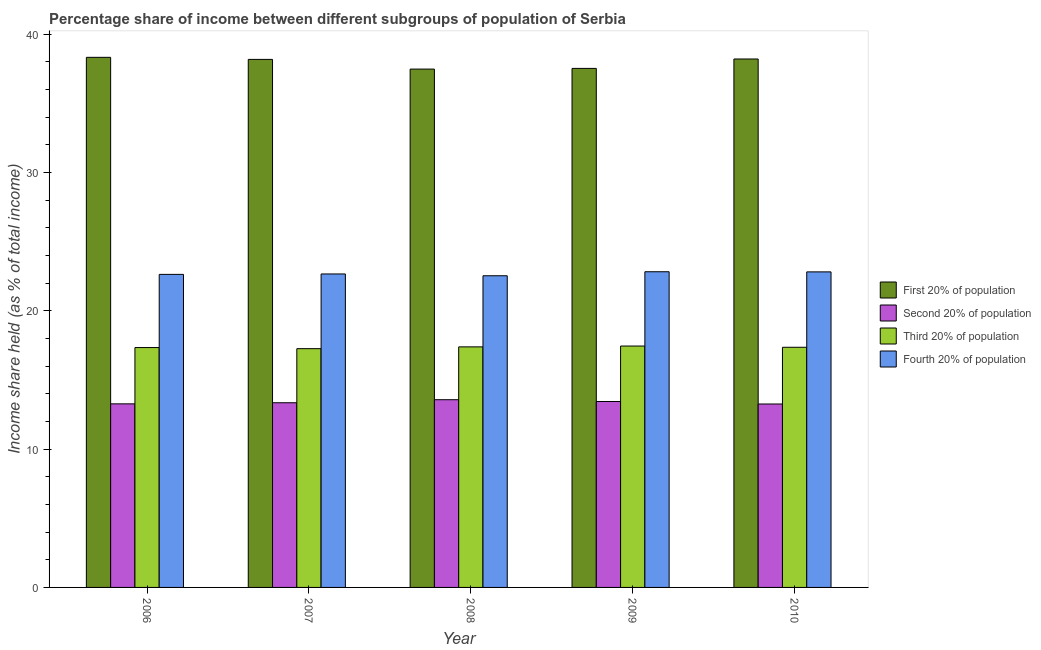Are the number of bars per tick equal to the number of legend labels?
Ensure brevity in your answer.  Yes. How many bars are there on the 2nd tick from the left?
Keep it short and to the point. 4. What is the label of the 2nd group of bars from the left?
Offer a very short reply. 2007. What is the share of the income held by fourth 20% of the population in 2007?
Offer a terse response. 22.66. Across all years, what is the maximum share of the income held by fourth 20% of the population?
Keep it short and to the point. 22.82. Across all years, what is the minimum share of the income held by first 20% of the population?
Offer a very short reply. 37.47. What is the total share of the income held by second 20% of the population in the graph?
Ensure brevity in your answer.  66.89. What is the difference between the share of the income held by third 20% of the population in 2006 and that in 2010?
Ensure brevity in your answer.  -0.02. What is the difference between the share of the income held by first 20% of the population in 2007 and the share of the income held by third 20% of the population in 2006?
Offer a very short reply. -0.15. What is the average share of the income held by third 20% of the population per year?
Provide a short and direct response. 17.36. What is the ratio of the share of the income held by first 20% of the population in 2006 to that in 2007?
Keep it short and to the point. 1. Is the difference between the share of the income held by second 20% of the population in 2008 and 2010 greater than the difference between the share of the income held by first 20% of the population in 2008 and 2010?
Offer a terse response. No. What is the difference between the highest and the second highest share of the income held by first 20% of the population?
Keep it short and to the point. 0.12. What is the difference between the highest and the lowest share of the income held by third 20% of the population?
Offer a terse response. 0.19. In how many years, is the share of the income held by third 20% of the population greater than the average share of the income held by third 20% of the population taken over all years?
Give a very brief answer. 2. What does the 4th bar from the left in 2009 represents?
Make the answer very short. Fourth 20% of population. What does the 3rd bar from the right in 2009 represents?
Offer a very short reply. Second 20% of population. Is it the case that in every year, the sum of the share of the income held by first 20% of the population and share of the income held by second 20% of the population is greater than the share of the income held by third 20% of the population?
Offer a terse response. Yes. How many years are there in the graph?
Your answer should be very brief. 5. What is the difference between two consecutive major ticks on the Y-axis?
Provide a short and direct response. 10. Are the values on the major ticks of Y-axis written in scientific E-notation?
Offer a very short reply. No. Does the graph contain grids?
Provide a short and direct response. No. Where does the legend appear in the graph?
Your answer should be compact. Center right. How are the legend labels stacked?
Offer a terse response. Vertical. What is the title of the graph?
Offer a very short reply. Percentage share of income between different subgroups of population of Serbia. What is the label or title of the Y-axis?
Ensure brevity in your answer.  Income share held (as % of total income). What is the Income share held (as % of total income) in First 20% of population in 2006?
Provide a short and direct response. 38.32. What is the Income share held (as % of total income) of Second 20% of population in 2006?
Provide a short and direct response. 13.27. What is the Income share held (as % of total income) of Third 20% of population in 2006?
Your answer should be very brief. 17.34. What is the Income share held (as % of total income) in Fourth 20% of population in 2006?
Your answer should be very brief. 22.63. What is the Income share held (as % of total income) of First 20% of population in 2007?
Make the answer very short. 38.17. What is the Income share held (as % of total income) of Second 20% of population in 2007?
Provide a short and direct response. 13.35. What is the Income share held (as % of total income) of Third 20% of population in 2007?
Provide a succinct answer. 17.26. What is the Income share held (as % of total income) of Fourth 20% of population in 2007?
Ensure brevity in your answer.  22.66. What is the Income share held (as % of total income) in First 20% of population in 2008?
Offer a terse response. 37.47. What is the Income share held (as % of total income) in Second 20% of population in 2008?
Provide a short and direct response. 13.57. What is the Income share held (as % of total income) in Third 20% of population in 2008?
Your answer should be compact. 17.39. What is the Income share held (as % of total income) of Fourth 20% of population in 2008?
Offer a terse response. 22.53. What is the Income share held (as % of total income) in First 20% of population in 2009?
Offer a very short reply. 37.52. What is the Income share held (as % of total income) of Second 20% of population in 2009?
Your response must be concise. 13.44. What is the Income share held (as % of total income) in Third 20% of population in 2009?
Keep it short and to the point. 17.45. What is the Income share held (as % of total income) in Fourth 20% of population in 2009?
Make the answer very short. 22.82. What is the Income share held (as % of total income) in First 20% of population in 2010?
Your answer should be compact. 38.2. What is the Income share held (as % of total income) in Second 20% of population in 2010?
Make the answer very short. 13.26. What is the Income share held (as % of total income) in Third 20% of population in 2010?
Offer a terse response. 17.36. What is the Income share held (as % of total income) in Fourth 20% of population in 2010?
Your answer should be very brief. 22.81. Across all years, what is the maximum Income share held (as % of total income) in First 20% of population?
Make the answer very short. 38.32. Across all years, what is the maximum Income share held (as % of total income) of Second 20% of population?
Give a very brief answer. 13.57. Across all years, what is the maximum Income share held (as % of total income) in Third 20% of population?
Your answer should be compact. 17.45. Across all years, what is the maximum Income share held (as % of total income) of Fourth 20% of population?
Your answer should be compact. 22.82. Across all years, what is the minimum Income share held (as % of total income) in First 20% of population?
Your answer should be very brief. 37.47. Across all years, what is the minimum Income share held (as % of total income) in Second 20% of population?
Offer a very short reply. 13.26. Across all years, what is the minimum Income share held (as % of total income) of Third 20% of population?
Give a very brief answer. 17.26. Across all years, what is the minimum Income share held (as % of total income) in Fourth 20% of population?
Your answer should be very brief. 22.53. What is the total Income share held (as % of total income) in First 20% of population in the graph?
Make the answer very short. 189.68. What is the total Income share held (as % of total income) in Second 20% of population in the graph?
Give a very brief answer. 66.89. What is the total Income share held (as % of total income) in Third 20% of population in the graph?
Your response must be concise. 86.8. What is the total Income share held (as % of total income) in Fourth 20% of population in the graph?
Provide a succinct answer. 113.45. What is the difference between the Income share held (as % of total income) in Second 20% of population in 2006 and that in 2007?
Provide a short and direct response. -0.08. What is the difference between the Income share held (as % of total income) of Fourth 20% of population in 2006 and that in 2007?
Your answer should be very brief. -0.03. What is the difference between the Income share held (as % of total income) in First 20% of population in 2006 and that in 2008?
Make the answer very short. 0.85. What is the difference between the Income share held (as % of total income) in Third 20% of population in 2006 and that in 2008?
Ensure brevity in your answer.  -0.05. What is the difference between the Income share held (as % of total income) of Fourth 20% of population in 2006 and that in 2008?
Make the answer very short. 0.1. What is the difference between the Income share held (as % of total income) in Second 20% of population in 2006 and that in 2009?
Make the answer very short. -0.17. What is the difference between the Income share held (as % of total income) in Third 20% of population in 2006 and that in 2009?
Provide a succinct answer. -0.11. What is the difference between the Income share held (as % of total income) in Fourth 20% of population in 2006 and that in 2009?
Keep it short and to the point. -0.19. What is the difference between the Income share held (as % of total income) of First 20% of population in 2006 and that in 2010?
Your answer should be very brief. 0.12. What is the difference between the Income share held (as % of total income) of Second 20% of population in 2006 and that in 2010?
Keep it short and to the point. 0.01. What is the difference between the Income share held (as % of total income) of Third 20% of population in 2006 and that in 2010?
Provide a succinct answer. -0.02. What is the difference between the Income share held (as % of total income) in Fourth 20% of population in 2006 and that in 2010?
Make the answer very short. -0.18. What is the difference between the Income share held (as % of total income) in Second 20% of population in 2007 and that in 2008?
Your answer should be compact. -0.22. What is the difference between the Income share held (as % of total income) of Third 20% of population in 2007 and that in 2008?
Keep it short and to the point. -0.13. What is the difference between the Income share held (as % of total income) in Fourth 20% of population in 2007 and that in 2008?
Your answer should be compact. 0.13. What is the difference between the Income share held (as % of total income) in First 20% of population in 2007 and that in 2009?
Keep it short and to the point. 0.65. What is the difference between the Income share held (as % of total income) of Second 20% of population in 2007 and that in 2009?
Provide a succinct answer. -0.09. What is the difference between the Income share held (as % of total income) in Third 20% of population in 2007 and that in 2009?
Make the answer very short. -0.19. What is the difference between the Income share held (as % of total income) in Fourth 20% of population in 2007 and that in 2009?
Your answer should be compact. -0.16. What is the difference between the Income share held (as % of total income) in First 20% of population in 2007 and that in 2010?
Offer a terse response. -0.03. What is the difference between the Income share held (as % of total income) of Second 20% of population in 2007 and that in 2010?
Offer a very short reply. 0.09. What is the difference between the Income share held (as % of total income) of Fourth 20% of population in 2007 and that in 2010?
Provide a short and direct response. -0.15. What is the difference between the Income share held (as % of total income) in Second 20% of population in 2008 and that in 2009?
Offer a terse response. 0.13. What is the difference between the Income share held (as % of total income) of Third 20% of population in 2008 and that in 2009?
Provide a short and direct response. -0.06. What is the difference between the Income share held (as % of total income) in Fourth 20% of population in 2008 and that in 2009?
Your answer should be compact. -0.29. What is the difference between the Income share held (as % of total income) of First 20% of population in 2008 and that in 2010?
Give a very brief answer. -0.73. What is the difference between the Income share held (as % of total income) in Second 20% of population in 2008 and that in 2010?
Give a very brief answer. 0.31. What is the difference between the Income share held (as % of total income) in Fourth 20% of population in 2008 and that in 2010?
Your response must be concise. -0.28. What is the difference between the Income share held (as % of total income) of First 20% of population in 2009 and that in 2010?
Your answer should be compact. -0.68. What is the difference between the Income share held (as % of total income) of Second 20% of population in 2009 and that in 2010?
Your answer should be compact. 0.18. What is the difference between the Income share held (as % of total income) of Third 20% of population in 2009 and that in 2010?
Provide a short and direct response. 0.09. What is the difference between the Income share held (as % of total income) of Fourth 20% of population in 2009 and that in 2010?
Make the answer very short. 0.01. What is the difference between the Income share held (as % of total income) of First 20% of population in 2006 and the Income share held (as % of total income) of Second 20% of population in 2007?
Offer a very short reply. 24.97. What is the difference between the Income share held (as % of total income) in First 20% of population in 2006 and the Income share held (as % of total income) in Third 20% of population in 2007?
Offer a very short reply. 21.06. What is the difference between the Income share held (as % of total income) in First 20% of population in 2006 and the Income share held (as % of total income) in Fourth 20% of population in 2007?
Provide a succinct answer. 15.66. What is the difference between the Income share held (as % of total income) in Second 20% of population in 2006 and the Income share held (as % of total income) in Third 20% of population in 2007?
Keep it short and to the point. -3.99. What is the difference between the Income share held (as % of total income) of Second 20% of population in 2006 and the Income share held (as % of total income) of Fourth 20% of population in 2007?
Make the answer very short. -9.39. What is the difference between the Income share held (as % of total income) in Third 20% of population in 2006 and the Income share held (as % of total income) in Fourth 20% of population in 2007?
Your response must be concise. -5.32. What is the difference between the Income share held (as % of total income) in First 20% of population in 2006 and the Income share held (as % of total income) in Second 20% of population in 2008?
Ensure brevity in your answer.  24.75. What is the difference between the Income share held (as % of total income) of First 20% of population in 2006 and the Income share held (as % of total income) of Third 20% of population in 2008?
Your answer should be compact. 20.93. What is the difference between the Income share held (as % of total income) in First 20% of population in 2006 and the Income share held (as % of total income) in Fourth 20% of population in 2008?
Ensure brevity in your answer.  15.79. What is the difference between the Income share held (as % of total income) of Second 20% of population in 2006 and the Income share held (as % of total income) of Third 20% of population in 2008?
Offer a terse response. -4.12. What is the difference between the Income share held (as % of total income) of Second 20% of population in 2006 and the Income share held (as % of total income) of Fourth 20% of population in 2008?
Your response must be concise. -9.26. What is the difference between the Income share held (as % of total income) of Third 20% of population in 2006 and the Income share held (as % of total income) of Fourth 20% of population in 2008?
Provide a succinct answer. -5.19. What is the difference between the Income share held (as % of total income) of First 20% of population in 2006 and the Income share held (as % of total income) of Second 20% of population in 2009?
Your answer should be very brief. 24.88. What is the difference between the Income share held (as % of total income) in First 20% of population in 2006 and the Income share held (as % of total income) in Third 20% of population in 2009?
Ensure brevity in your answer.  20.87. What is the difference between the Income share held (as % of total income) of First 20% of population in 2006 and the Income share held (as % of total income) of Fourth 20% of population in 2009?
Your response must be concise. 15.5. What is the difference between the Income share held (as % of total income) of Second 20% of population in 2006 and the Income share held (as % of total income) of Third 20% of population in 2009?
Offer a very short reply. -4.18. What is the difference between the Income share held (as % of total income) of Second 20% of population in 2006 and the Income share held (as % of total income) of Fourth 20% of population in 2009?
Offer a very short reply. -9.55. What is the difference between the Income share held (as % of total income) of Third 20% of population in 2006 and the Income share held (as % of total income) of Fourth 20% of population in 2009?
Make the answer very short. -5.48. What is the difference between the Income share held (as % of total income) of First 20% of population in 2006 and the Income share held (as % of total income) of Second 20% of population in 2010?
Your answer should be very brief. 25.06. What is the difference between the Income share held (as % of total income) in First 20% of population in 2006 and the Income share held (as % of total income) in Third 20% of population in 2010?
Make the answer very short. 20.96. What is the difference between the Income share held (as % of total income) of First 20% of population in 2006 and the Income share held (as % of total income) of Fourth 20% of population in 2010?
Provide a succinct answer. 15.51. What is the difference between the Income share held (as % of total income) in Second 20% of population in 2006 and the Income share held (as % of total income) in Third 20% of population in 2010?
Offer a very short reply. -4.09. What is the difference between the Income share held (as % of total income) in Second 20% of population in 2006 and the Income share held (as % of total income) in Fourth 20% of population in 2010?
Offer a very short reply. -9.54. What is the difference between the Income share held (as % of total income) of Third 20% of population in 2006 and the Income share held (as % of total income) of Fourth 20% of population in 2010?
Give a very brief answer. -5.47. What is the difference between the Income share held (as % of total income) in First 20% of population in 2007 and the Income share held (as % of total income) in Second 20% of population in 2008?
Your answer should be very brief. 24.6. What is the difference between the Income share held (as % of total income) of First 20% of population in 2007 and the Income share held (as % of total income) of Third 20% of population in 2008?
Ensure brevity in your answer.  20.78. What is the difference between the Income share held (as % of total income) in First 20% of population in 2007 and the Income share held (as % of total income) in Fourth 20% of population in 2008?
Make the answer very short. 15.64. What is the difference between the Income share held (as % of total income) in Second 20% of population in 2007 and the Income share held (as % of total income) in Third 20% of population in 2008?
Offer a terse response. -4.04. What is the difference between the Income share held (as % of total income) in Second 20% of population in 2007 and the Income share held (as % of total income) in Fourth 20% of population in 2008?
Your response must be concise. -9.18. What is the difference between the Income share held (as % of total income) in Third 20% of population in 2007 and the Income share held (as % of total income) in Fourth 20% of population in 2008?
Your answer should be very brief. -5.27. What is the difference between the Income share held (as % of total income) in First 20% of population in 2007 and the Income share held (as % of total income) in Second 20% of population in 2009?
Provide a succinct answer. 24.73. What is the difference between the Income share held (as % of total income) of First 20% of population in 2007 and the Income share held (as % of total income) of Third 20% of population in 2009?
Give a very brief answer. 20.72. What is the difference between the Income share held (as % of total income) of First 20% of population in 2007 and the Income share held (as % of total income) of Fourth 20% of population in 2009?
Provide a succinct answer. 15.35. What is the difference between the Income share held (as % of total income) in Second 20% of population in 2007 and the Income share held (as % of total income) in Third 20% of population in 2009?
Your response must be concise. -4.1. What is the difference between the Income share held (as % of total income) in Second 20% of population in 2007 and the Income share held (as % of total income) in Fourth 20% of population in 2009?
Provide a short and direct response. -9.47. What is the difference between the Income share held (as % of total income) in Third 20% of population in 2007 and the Income share held (as % of total income) in Fourth 20% of population in 2009?
Your response must be concise. -5.56. What is the difference between the Income share held (as % of total income) of First 20% of population in 2007 and the Income share held (as % of total income) of Second 20% of population in 2010?
Your answer should be compact. 24.91. What is the difference between the Income share held (as % of total income) in First 20% of population in 2007 and the Income share held (as % of total income) in Third 20% of population in 2010?
Your response must be concise. 20.81. What is the difference between the Income share held (as % of total income) of First 20% of population in 2007 and the Income share held (as % of total income) of Fourth 20% of population in 2010?
Your answer should be compact. 15.36. What is the difference between the Income share held (as % of total income) of Second 20% of population in 2007 and the Income share held (as % of total income) of Third 20% of population in 2010?
Offer a terse response. -4.01. What is the difference between the Income share held (as % of total income) of Second 20% of population in 2007 and the Income share held (as % of total income) of Fourth 20% of population in 2010?
Give a very brief answer. -9.46. What is the difference between the Income share held (as % of total income) of Third 20% of population in 2007 and the Income share held (as % of total income) of Fourth 20% of population in 2010?
Your answer should be very brief. -5.55. What is the difference between the Income share held (as % of total income) in First 20% of population in 2008 and the Income share held (as % of total income) in Second 20% of population in 2009?
Keep it short and to the point. 24.03. What is the difference between the Income share held (as % of total income) in First 20% of population in 2008 and the Income share held (as % of total income) in Third 20% of population in 2009?
Provide a succinct answer. 20.02. What is the difference between the Income share held (as % of total income) in First 20% of population in 2008 and the Income share held (as % of total income) in Fourth 20% of population in 2009?
Your answer should be very brief. 14.65. What is the difference between the Income share held (as % of total income) of Second 20% of population in 2008 and the Income share held (as % of total income) of Third 20% of population in 2009?
Provide a short and direct response. -3.88. What is the difference between the Income share held (as % of total income) in Second 20% of population in 2008 and the Income share held (as % of total income) in Fourth 20% of population in 2009?
Provide a succinct answer. -9.25. What is the difference between the Income share held (as % of total income) of Third 20% of population in 2008 and the Income share held (as % of total income) of Fourth 20% of population in 2009?
Ensure brevity in your answer.  -5.43. What is the difference between the Income share held (as % of total income) in First 20% of population in 2008 and the Income share held (as % of total income) in Second 20% of population in 2010?
Provide a short and direct response. 24.21. What is the difference between the Income share held (as % of total income) in First 20% of population in 2008 and the Income share held (as % of total income) in Third 20% of population in 2010?
Ensure brevity in your answer.  20.11. What is the difference between the Income share held (as % of total income) in First 20% of population in 2008 and the Income share held (as % of total income) in Fourth 20% of population in 2010?
Ensure brevity in your answer.  14.66. What is the difference between the Income share held (as % of total income) of Second 20% of population in 2008 and the Income share held (as % of total income) of Third 20% of population in 2010?
Offer a terse response. -3.79. What is the difference between the Income share held (as % of total income) in Second 20% of population in 2008 and the Income share held (as % of total income) in Fourth 20% of population in 2010?
Your response must be concise. -9.24. What is the difference between the Income share held (as % of total income) in Third 20% of population in 2008 and the Income share held (as % of total income) in Fourth 20% of population in 2010?
Your answer should be very brief. -5.42. What is the difference between the Income share held (as % of total income) in First 20% of population in 2009 and the Income share held (as % of total income) in Second 20% of population in 2010?
Your answer should be very brief. 24.26. What is the difference between the Income share held (as % of total income) in First 20% of population in 2009 and the Income share held (as % of total income) in Third 20% of population in 2010?
Offer a terse response. 20.16. What is the difference between the Income share held (as % of total income) in First 20% of population in 2009 and the Income share held (as % of total income) in Fourth 20% of population in 2010?
Offer a terse response. 14.71. What is the difference between the Income share held (as % of total income) in Second 20% of population in 2009 and the Income share held (as % of total income) in Third 20% of population in 2010?
Offer a very short reply. -3.92. What is the difference between the Income share held (as % of total income) of Second 20% of population in 2009 and the Income share held (as % of total income) of Fourth 20% of population in 2010?
Keep it short and to the point. -9.37. What is the difference between the Income share held (as % of total income) in Third 20% of population in 2009 and the Income share held (as % of total income) in Fourth 20% of population in 2010?
Offer a terse response. -5.36. What is the average Income share held (as % of total income) in First 20% of population per year?
Your response must be concise. 37.94. What is the average Income share held (as % of total income) in Second 20% of population per year?
Keep it short and to the point. 13.38. What is the average Income share held (as % of total income) of Third 20% of population per year?
Keep it short and to the point. 17.36. What is the average Income share held (as % of total income) of Fourth 20% of population per year?
Provide a succinct answer. 22.69. In the year 2006, what is the difference between the Income share held (as % of total income) in First 20% of population and Income share held (as % of total income) in Second 20% of population?
Provide a succinct answer. 25.05. In the year 2006, what is the difference between the Income share held (as % of total income) in First 20% of population and Income share held (as % of total income) in Third 20% of population?
Offer a very short reply. 20.98. In the year 2006, what is the difference between the Income share held (as % of total income) of First 20% of population and Income share held (as % of total income) of Fourth 20% of population?
Provide a short and direct response. 15.69. In the year 2006, what is the difference between the Income share held (as % of total income) in Second 20% of population and Income share held (as % of total income) in Third 20% of population?
Offer a terse response. -4.07. In the year 2006, what is the difference between the Income share held (as % of total income) in Second 20% of population and Income share held (as % of total income) in Fourth 20% of population?
Give a very brief answer. -9.36. In the year 2006, what is the difference between the Income share held (as % of total income) of Third 20% of population and Income share held (as % of total income) of Fourth 20% of population?
Your response must be concise. -5.29. In the year 2007, what is the difference between the Income share held (as % of total income) in First 20% of population and Income share held (as % of total income) in Second 20% of population?
Ensure brevity in your answer.  24.82. In the year 2007, what is the difference between the Income share held (as % of total income) of First 20% of population and Income share held (as % of total income) of Third 20% of population?
Offer a terse response. 20.91. In the year 2007, what is the difference between the Income share held (as % of total income) in First 20% of population and Income share held (as % of total income) in Fourth 20% of population?
Provide a short and direct response. 15.51. In the year 2007, what is the difference between the Income share held (as % of total income) of Second 20% of population and Income share held (as % of total income) of Third 20% of population?
Provide a short and direct response. -3.91. In the year 2007, what is the difference between the Income share held (as % of total income) of Second 20% of population and Income share held (as % of total income) of Fourth 20% of population?
Give a very brief answer. -9.31. In the year 2008, what is the difference between the Income share held (as % of total income) in First 20% of population and Income share held (as % of total income) in Second 20% of population?
Ensure brevity in your answer.  23.9. In the year 2008, what is the difference between the Income share held (as % of total income) in First 20% of population and Income share held (as % of total income) in Third 20% of population?
Provide a succinct answer. 20.08. In the year 2008, what is the difference between the Income share held (as % of total income) of First 20% of population and Income share held (as % of total income) of Fourth 20% of population?
Your answer should be very brief. 14.94. In the year 2008, what is the difference between the Income share held (as % of total income) of Second 20% of population and Income share held (as % of total income) of Third 20% of population?
Provide a succinct answer. -3.82. In the year 2008, what is the difference between the Income share held (as % of total income) in Second 20% of population and Income share held (as % of total income) in Fourth 20% of population?
Provide a succinct answer. -8.96. In the year 2008, what is the difference between the Income share held (as % of total income) in Third 20% of population and Income share held (as % of total income) in Fourth 20% of population?
Offer a terse response. -5.14. In the year 2009, what is the difference between the Income share held (as % of total income) in First 20% of population and Income share held (as % of total income) in Second 20% of population?
Your answer should be very brief. 24.08. In the year 2009, what is the difference between the Income share held (as % of total income) of First 20% of population and Income share held (as % of total income) of Third 20% of population?
Offer a very short reply. 20.07. In the year 2009, what is the difference between the Income share held (as % of total income) in First 20% of population and Income share held (as % of total income) in Fourth 20% of population?
Give a very brief answer. 14.7. In the year 2009, what is the difference between the Income share held (as % of total income) of Second 20% of population and Income share held (as % of total income) of Third 20% of population?
Your answer should be very brief. -4.01. In the year 2009, what is the difference between the Income share held (as % of total income) in Second 20% of population and Income share held (as % of total income) in Fourth 20% of population?
Your answer should be very brief. -9.38. In the year 2009, what is the difference between the Income share held (as % of total income) of Third 20% of population and Income share held (as % of total income) of Fourth 20% of population?
Offer a terse response. -5.37. In the year 2010, what is the difference between the Income share held (as % of total income) of First 20% of population and Income share held (as % of total income) of Second 20% of population?
Make the answer very short. 24.94. In the year 2010, what is the difference between the Income share held (as % of total income) of First 20% of population and Income share held (as % of total income) of Third 20% of population?
Your response must be concise. 20.84. In the year 2010, what is the difference between the Income share held (as % of total income) in First 20% of population and Income share held (as % of total income) in Fourth 20% of population?
Your answer should be very brief. 15.39. In the year 2010, what is the difference between the Income share held (as % of total income) of Second 20% of population and Income share held (as % of total income) of Fourth 20% of population?
Offer a very short reply. -9.55. In the year 2010, what is the difference between the Income share held (as % of total income) in Third 20% of population and Income share held (as % of total income) in Fourth 20% of population?
Make the answer very short. -5.45. What is the ratio of the Income share held (as % of total income) of Third 20% of population in 2006 to that in 2007?
Ensure brevity in your answer.  1. What is the ratio of the Income share held (as % of total income) in Fourth 20% of population in 2006 to that in 2007?
Provide a short and direct response. 1. What is the ratio of the Income share held (as % of total income) in First 20% of population in 2006 to that in 2008?
Give a very brief answer. 1.02. What is the ratio of the Income share held (as % of total income) of Second 20% of population in 2006 to that in 2008?
Provide a succinct answer. 0.98. What is the ratio of the Income share held (as % of total income) in Fourth 20% of population in 2006 to that in 2008?
Your response must be concise. 1. What is the ratio of the Income share held (as % of total income) of First 20% of population in 2006 to that in 2009?
Provide a short and direct response. 1.02. What is the ratio of the Income share held (as % of total income) of Second 20% of population in 2006 to that in 2009?
Your response must be concise. 0.99. What is the ratio of the Income share held (as % of total income) of Third 20% of population in 2006 to that in 2009?
Provide a succinct answer. 0.99. What is the ratio of the Income share held (as % of total income) in Fourth 20% of population in 2006 to that in 2009?
Provide a succinct answer. 0.99. What is the ratio of the Income share held (as % of total income) in First 20% of population in 2006 to that in 2010?
Your answer should be very brief. 1. What is the ratio of the Income share held (as % of total income) in Third 20% of population in 2006 to that in 2010?
Provide a succinct answer. 1. What is the ratio of the Income share held (as % of total income) in First 20% of population in 2007 to that in 2008?
Keep it short and to the point. 1.02. What is the ratio of the Income share held (as % of total income) of Second 20% of population in 2007 to that in 2008?
Make the answer very short. 0.98. What is the ratio of the Income share held (as % of total income) in First 20% of population in 2007 to that in 2009?
Keep it short and to the point. 1.02. What is the ratio of the Income share held (as % of total income) in Second 20% of population in 2007 to that in 2009?
Keep it short and to the point. 0.99. What is the ratio of the Income share held (as % of total income) in Third 20% of population in 2007 to that in 2009?
Your answer should be compact. 0.99. What is the ratio of the Income share held (as % of total income) in First 20% of population in 2007 to that in 2010?
Offer a terse response. 1. What is the ratio of the Income share held (as % of total income) of Second 20% of population in 2007 to that in 2010?
Your answer should be compact. 1.01. What is the ratio of the Income share held (as % of total income) in Third 20% of population in 2007 to that in 2010?
Your answer should be very brief. 0.99. What is the ratio of the Income share held (as % of total income) of Fourth 20% of population in 2007 to that in 2010?
Your answer should be compact. 0.99. What is the ratio of the Income share held (as % of total income) in Second 20% of population in 2008 to that in 2009?
Your answer should be compact. 1.01. What is the ratio of the Income share held (as % of total income) in Third 20% of population in 2008 to that in 2009?
Make the answer very short. 1. What is the ratio of the Income share held (as % of total income) in Fourth 20% of population in 2008 to that in 2009?
Offer a very short reply. 0.99. What is the ratio of the Income share held (as % of total income) in First 20% of population in 2008 to that in 2010?
Provide a short and direct response. 0.98. What is the ratio of the Income share held (as % of total income) of Second 20% of population in 2008 to that in 2010?
Your answer should be compact. 1.02. What is the ratio of the Income share held (as % of total income) of Fourth 20% of population in 2008 to that in 2010?
Your response must be concise. 0.99. What is the ratio of the Income share held (as % of total income) in First 20% of population in 2009 to that in 2010?
Give a very brief answer. 0.98. What is the ratio of the Income share held (as % of total income) in Second 20% of population in 2009 to that in 2010?
Your answer should be very brief. 1.01. What is the ratio of the Income share held (as % of total income) in Fourth 20% of population in 2009 to that in 2010?
Keep it short and to the point. 1. What is the difference between the highest and the second highest Income share held (as % of total income) in First 20% of population?
Offer a terse response. 0.12. What is the difference between the highest and the second highest Income share held (as % of total income) in Second 20% of population?
Your response must be concise. 0.13. What is the difference between the highest and the lowest Income share held (as % of total income) of Second 20% of population?
Your response must be concise. 0.31. What is the difference between the highest and the lowest Income share held (as % of total income) in Third 20% of population?
Your answer should be very brief. 0.19. What is the difference between the highest and the lowest Income share held (as % of total income) of Fourth 20% of population?
Provide a short and direct response. 0.29. 